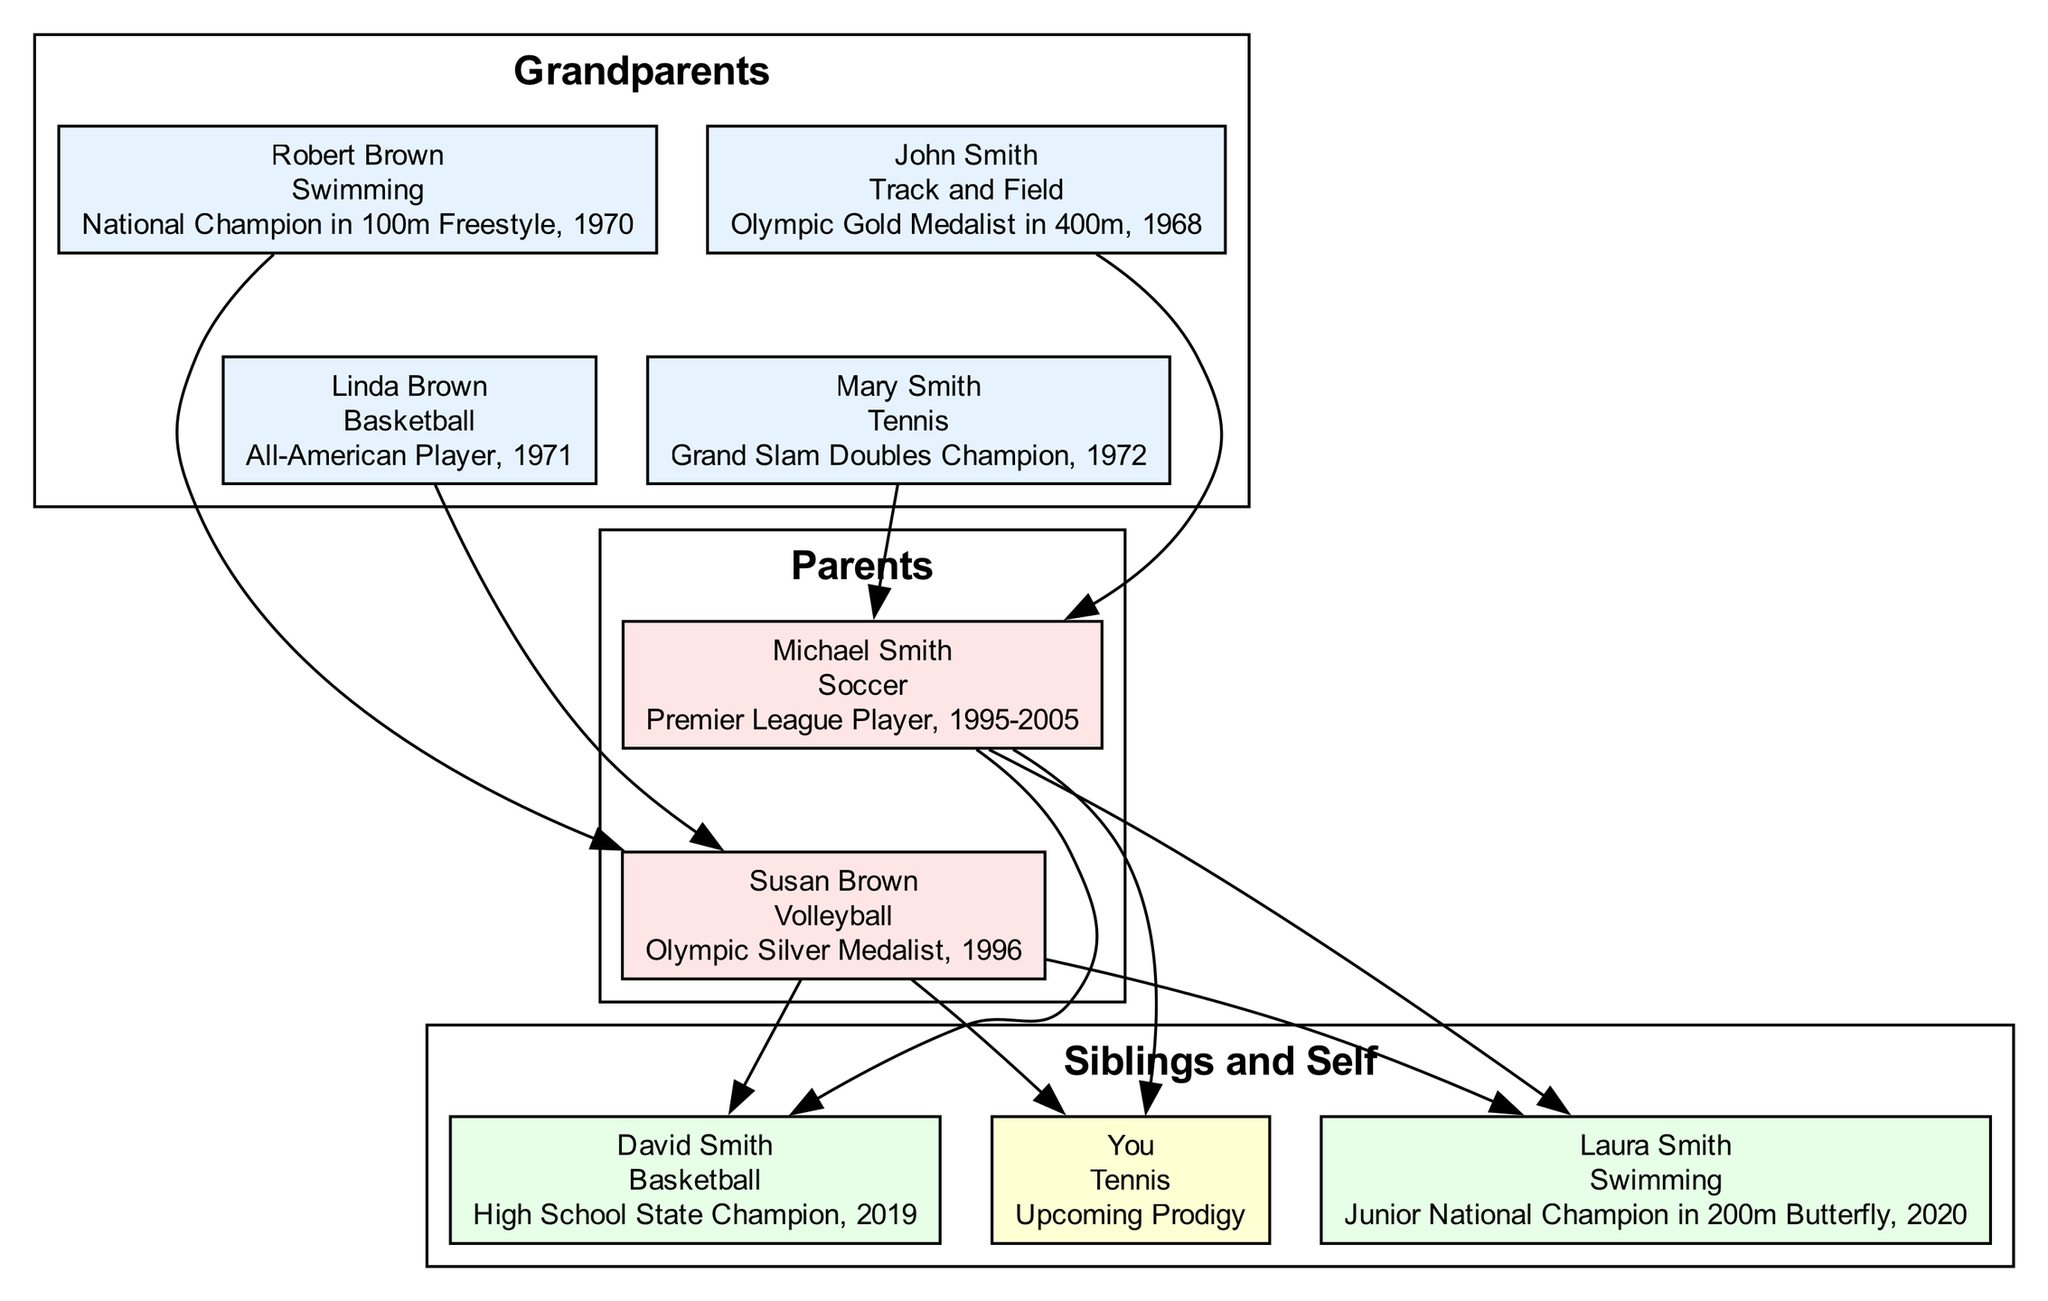What sport did John Smith compete in? The diagram indicates that John Smith is listed under paternal grandparents, specifically as the grandfather, and his sport is noted as Track and Field.
Answer: Track and Field Who is the Olympic Silver Medalist in the family? Looking at the parents' section of the diagram, Susan Brown is identified as the mother and is recognized as the Olympic Silver Medalist in 1996.
Answer: Susan Brown How many siblings are there? The siblings section of the diagram lists two individuals: Laura Smith and David Smith. Thus, by counting these names, the total number of siblings is determined to be two.
Answer: 2 What achievement is associated with Robert Brown? In the maternal grandparents section, Robert Brown is detailed as the grandfather, and his achievement is specified as National Champion in 100m Freestyle, 1970.
Answer: National Champion in 100m Freestyle, 1970 Which family member has the most recent athletic achievement? By analyzing the dates of achievements, Laura Smith, in 2020, is highlighted as the most recent with her title of Junior National Champion in 200m Butterfly. The others have achievements from earlier dates.
Answer: Laura Smith How are the siblings connected to the parents? The diagram shows that both siblings, Laura and David Smith, connect to the father (Michael Smith) and mother (Susan Brown) through directed edges, indicating a direct familial relationship.
Answer: By edges from parents What sport did Mary Smith achieve her title in? Within the paternal grandparents section, Mary Smith is identified as the grandmother, and her sport is Tennis, where she achieved the title of Grand Slam Doubles Champion in 1972.
Answer: Tennis Which grandparent participated in Basketball? The diagram indicates that Linda Brown is listed as the maternal grandmother and her sport is Basketball.
Answer: Basketball Who is the oldest grandparent in the family? By examining the names listed for grandparents, it's concluded that John Smith and Robert Brown are likely to be the oldest based on traditional naming conventions, but specific ages aren't provided in the diagram. Assuming the typical lifespan, John Smith can be considered the oldest among the male grandparents listed.
Answer: John Smith 